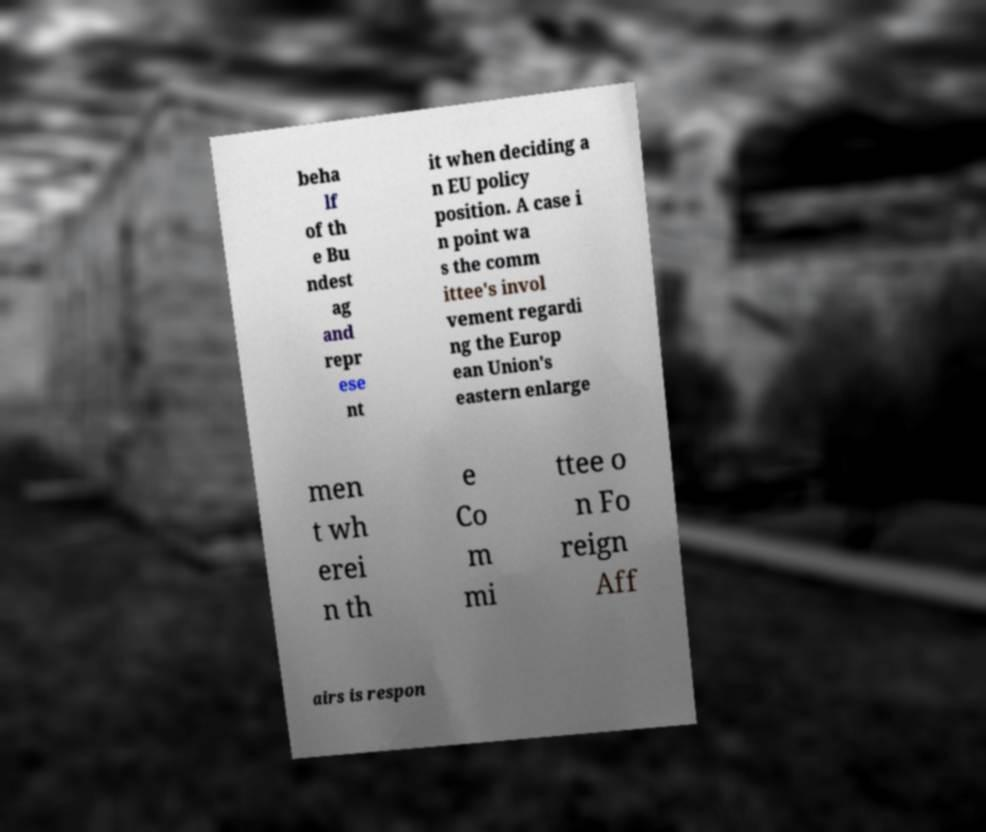I need the written content from this picture converted into text. Can you do that? beha lf of th e Bu ndest ag and repr ese nt it when deciding a n EU policy position. A case i n point wa s the comm ittee's invol vement regardi ng the Europ ean Union's eastern enlarge men t wh erei n th e Co m mi ttee o n Fo reign Aff airs is respon 